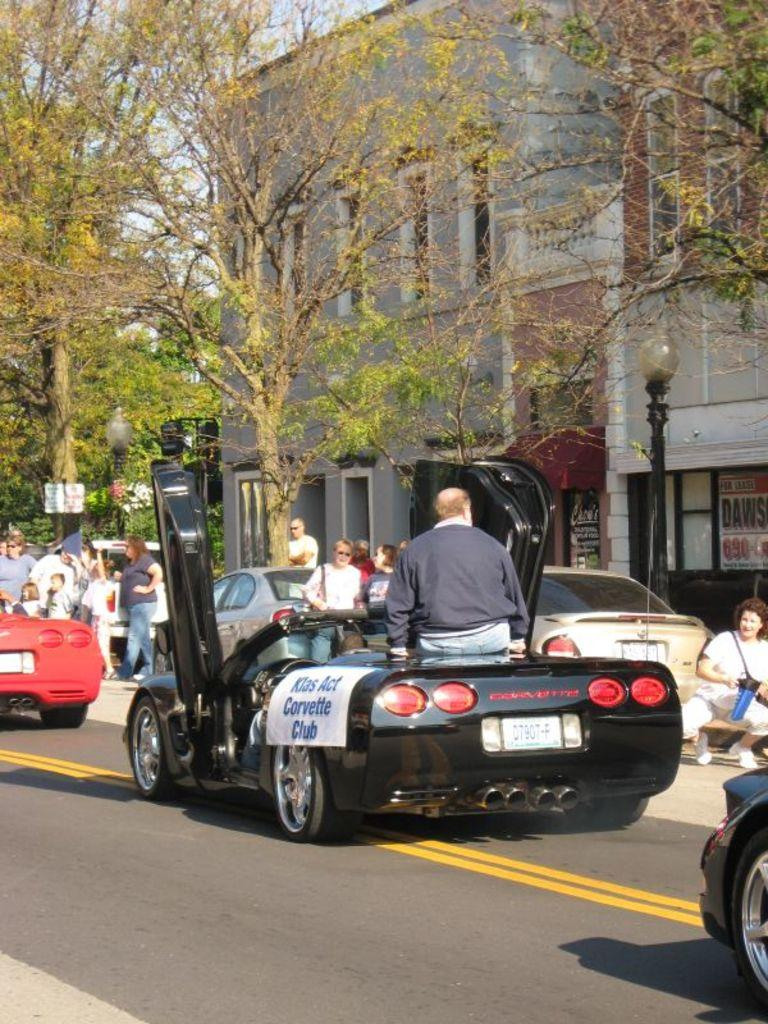What are the people in the image wearing? The persons in the image are wearing clothes. What can be seen on the road in the image? There are cars on the road in the image. What is located in front of the building in the image? There are trees in front of a building in the image. What is on the right side of the image? There is a pole on the right side of the image. What is the chance of winning the division in the image? There is no reference to a division or any competition in the image, so it's not possible to determine the chance of winning. 